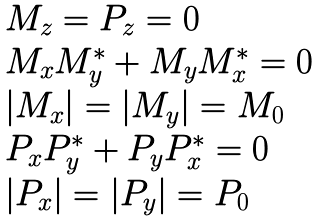<formula> <loc_0><loc_0><loc_500><loc_500>\begin{array} { l } M _ { z } = P _ { z } = 0 \\ M _ { x } M _ { y } ^ { \ast } + M _ { y } M _ { x } ^ { \ast } = 0 \\ { \left | { M _ { x } } \right | } = { \left | { M _ { y } } \right | } = M _ { 0 } \\ P _ { x } P _ { y } ^ { \ast } + P _ { y } P _ { x } ^ { \ast } = 0 \\ { \left | { P _ { x } } \right | } = { \left | { P _ { y } } \right | } = P _ { 0 } \\ \end{array}</formula> 